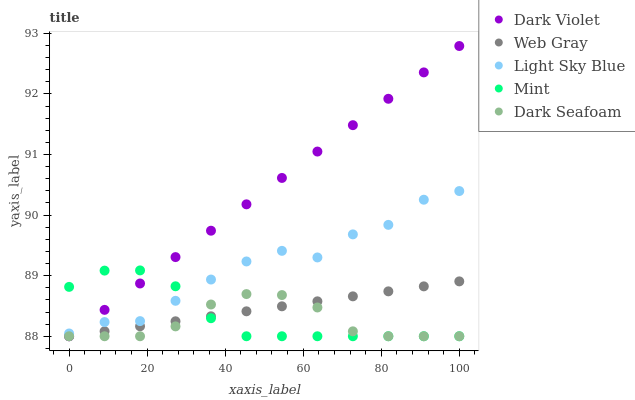Does Dark Seafoam have the minimum area under the curve?
Answer yes or no. Yes. Does Dark Violet have the maximum area under the curve?
Answer yes or no. Yes. Does Web Gray have the minimum area under the curve?
Answer yes or no. No. Does Web Gray have the maximum area under the curve?
Answer yes or no. No. Is Dark Violet the smoothest?
Answer yes or no. Yes. Is Light Sky Blue the roughest?
Answer yes or no. Yes. Is Web Gray the smoothest?
Answer yes or no. No. Is Web Gray the roughest?
Answer yes or no. No. Does Dark Seafoam have the lowest value?
Answer yes or no. Yes. Does Light Sky Blue have the lowest value?
Answer yes or no. No. Does Dark Violet have the highest value?
Answer yes or no. Yes. Does Web Gray have the highest value?
Answer yes or no. No. Is Web Gray less than Light Sky Blue?
Answer yes or no. Yes. Is Light Sky Blue greater than Web Gray?
Answer yes or no. Yes. Does Mint intersect Dark Violet?
Answer yes or no. Yes. Is Mint less than Dark Violet?
Answer yes or no. No. Is Mint greater than Dark Violet?
Answer yes or no. No. Does Web Gray intersect Light Sky Blue?
Answer yes or no. No. 